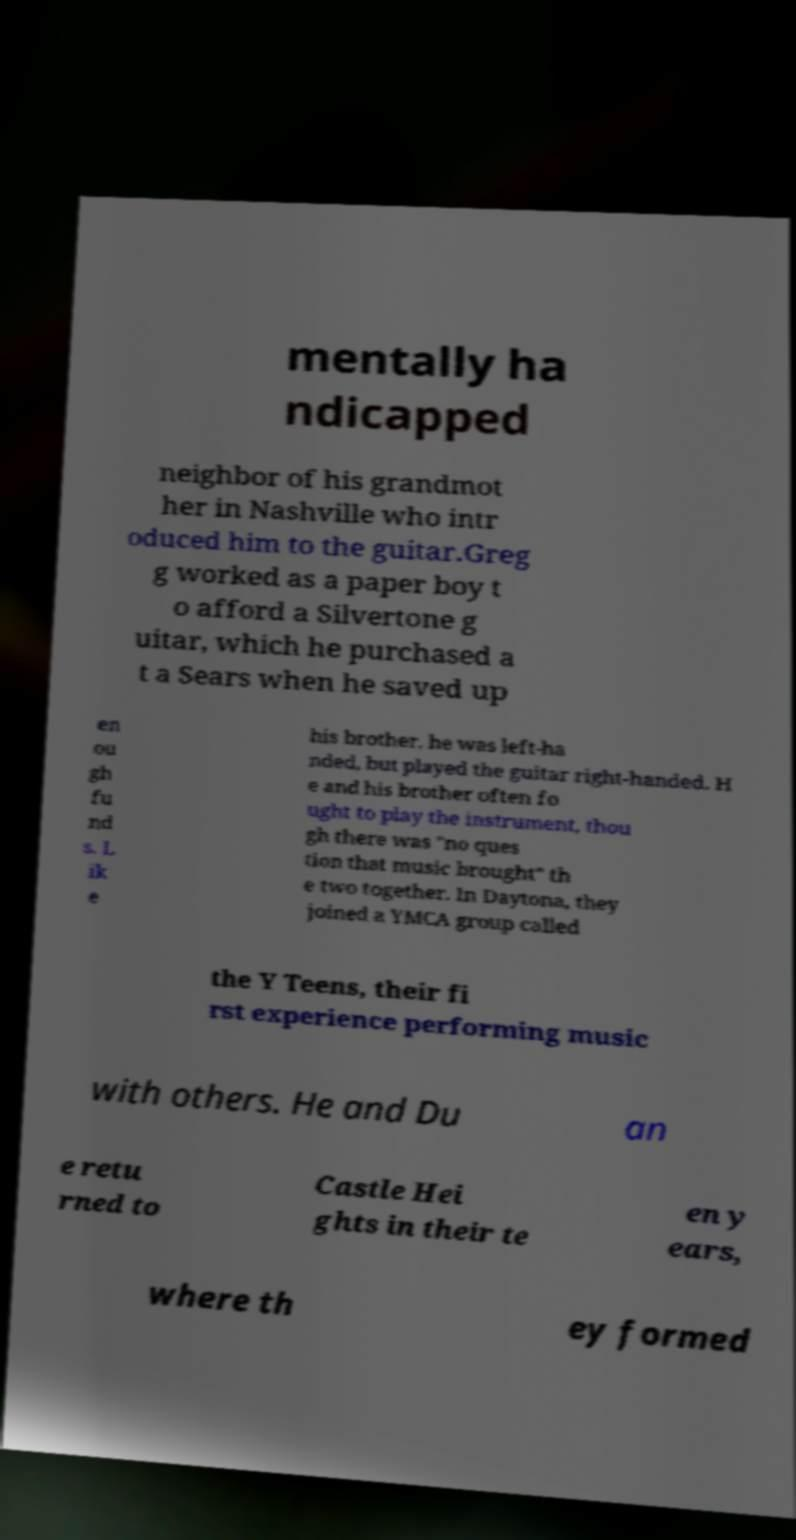Can you read and provide the text displayed in the image?This photo seems to have some interesting text. Can you extract and type it out for me? mentally ha ndicapped neighbor of his grandmot her in Nashville who intr oduced him to the guitar.Greg g worked as a paper boy t o afford a Silvertone g uitar, which he purchased a t a Sears when he saved up en ou gh fu nd s. L ik e his brother, he was left-ha nded, but played the guitar right-handed. H e and his brother often fo ught to play the instrument, thou gh there was "no ques tion that music brought" th e two together. In Daytona, they joined a YMCA group called the Y Teens, their fi rst experience performing music with others. He and Du an e retu rned to Castle Hei ghts in their te en y ears, where th ey formed 